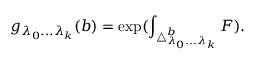Convert formula to latex. <formula><loc_0><loc_0><loc_500><loc_500>g _ { \lambda _ { 0 } \dots \lambda _ { k } } ( b ) = \exp ( \int _ { \triangle _ { \lambda _ { 0 } \dots \lambda _ { k } } ^ { b } } F ) .</formula> 